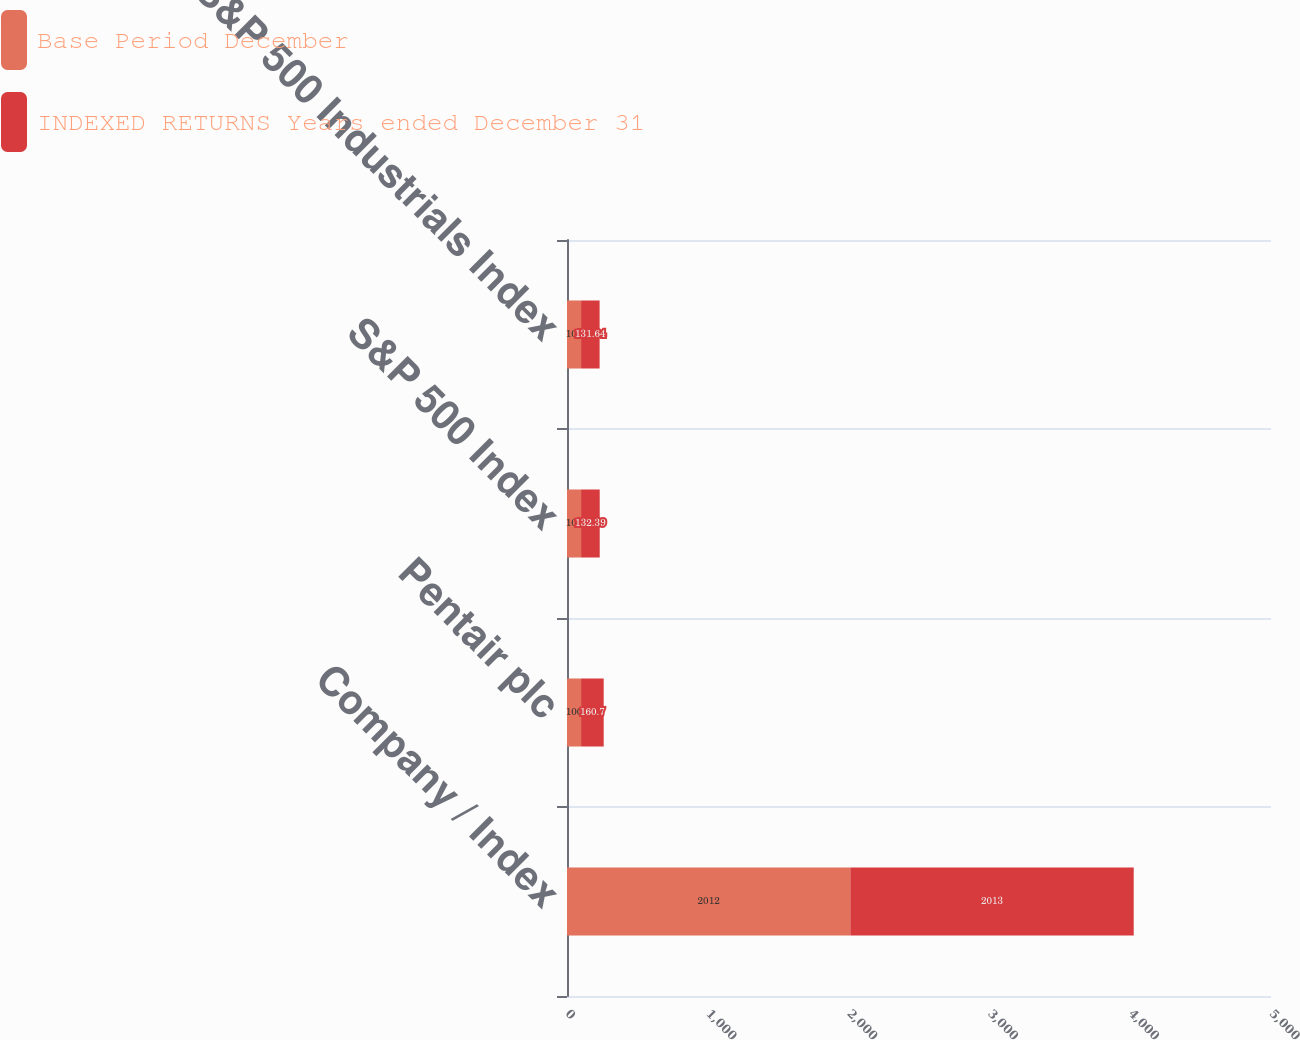Convert chart. <chart><loc_0><loc_0><loc_500><loc_500><stacked_bar_chart><ecel><fcel>Company / Index<fcel>Pentair plc<fcel>S&P 500 Index<fcel>S&P 500 Industrials Index<nl><fcel>Base Period December<fcel>2012<fcel>100<fcel>100<fcel>100<nl><fcel>INDEXED RETURNS Years ended December 31<fcel>2013<fcel>160.7<fcel>132.39<fcel>131.64<nl></chart> 